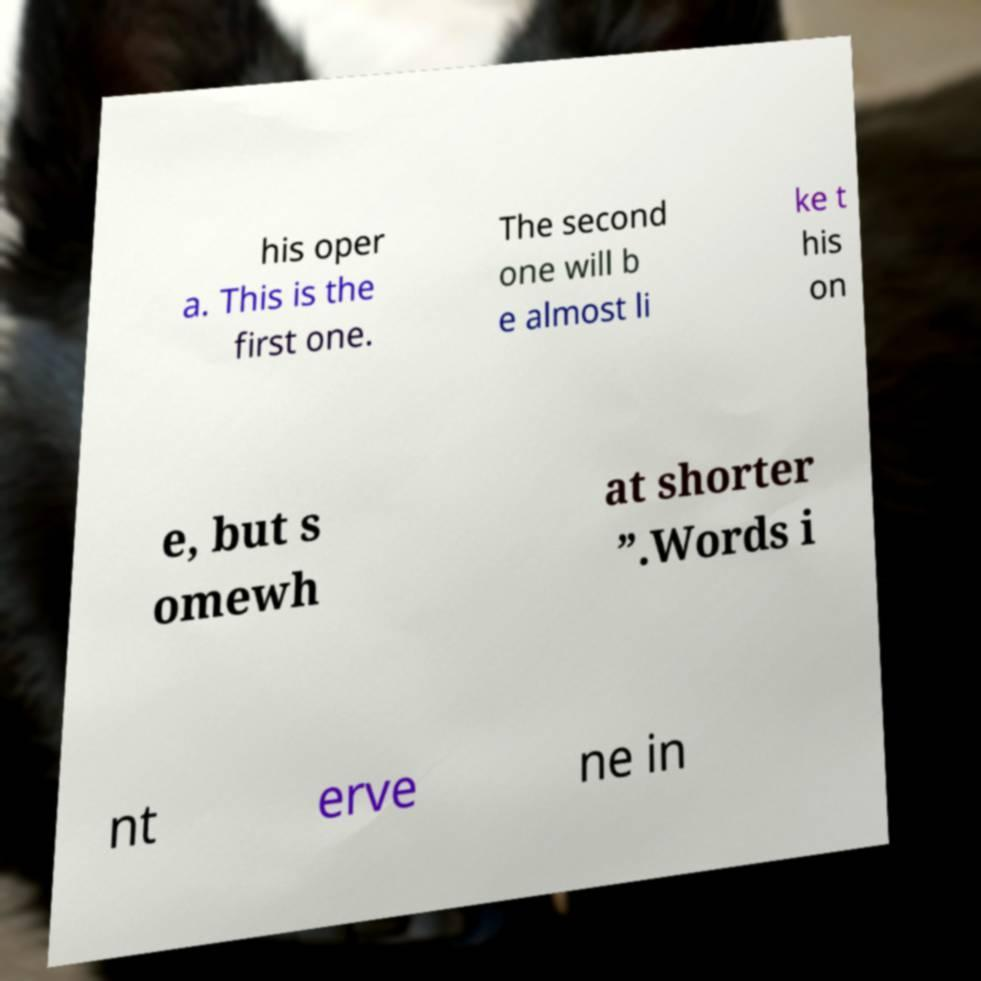What messages or text are displayed in this image? I need them in a readable, typed format. his oper a. This is the first one. The second one will b e almost li ke t his on e, but s omewh at shorter ”.Words i nt erve ne in 